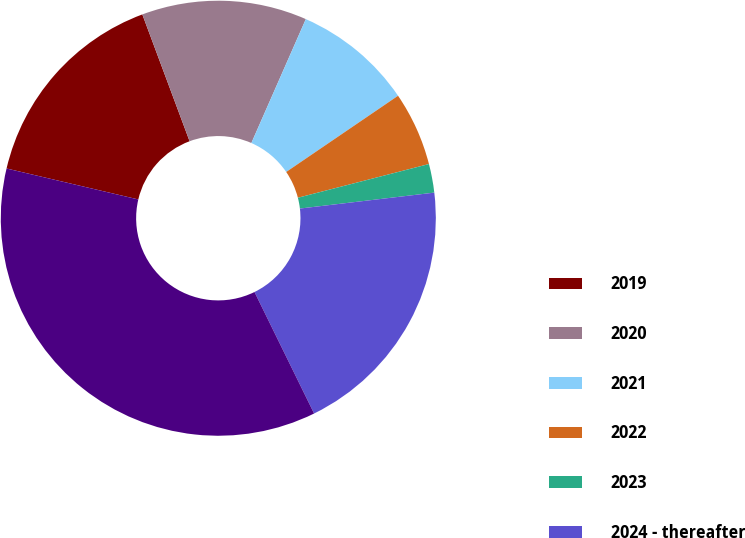<chart> <loc_0><loc_0><loc_500><loc_500><pie_chart><fcel>2019<fcel>2020<fcel>2021<fcel>2022<fcel>2023<fcel>2024 - thereafter<fcel>Total<nl><fcel>15.65%<fcel>12.27%<fcel>8.89%<fcel>5.51%<fcel>2.13%<fcel>19.62%<fcel>35.93%<nl></chart> 